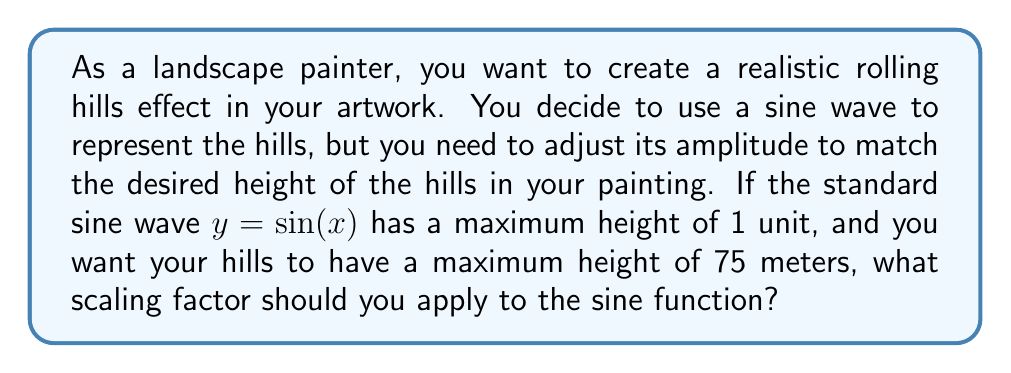Could you help me with this problem? To solve this problem, we need to understand how scaling affects the amplitude of a sine wave:

1. The standard sine function $y = \sin(x)$ has an amplitude of 1, meaning it oscillates between -1 and 1.

2. To scale the amplitude of a sine wave, we multiply the function by a scaling factor. The general form becomes:

   $y = A \sin(x)$

   where $A$ is the scaling factor.

3. The amplitude of the scaled sine wave will be equal to the absolute value of $A$.

4. In this case, we want the maximum height (amplitude) to be 75 meters. Therefore:

   $|A| = 75$

5. Since we're dealing with height, which is always positive in this context, we can simply use:

   $A = 75$

6. The resulting scaled sine function would be:

   $y = 75 \sin(x)$

This function will oscillate between -75 and 75, giving us hills with a maximum height of 75 meters.
Answer: The scaling factor is 75. 